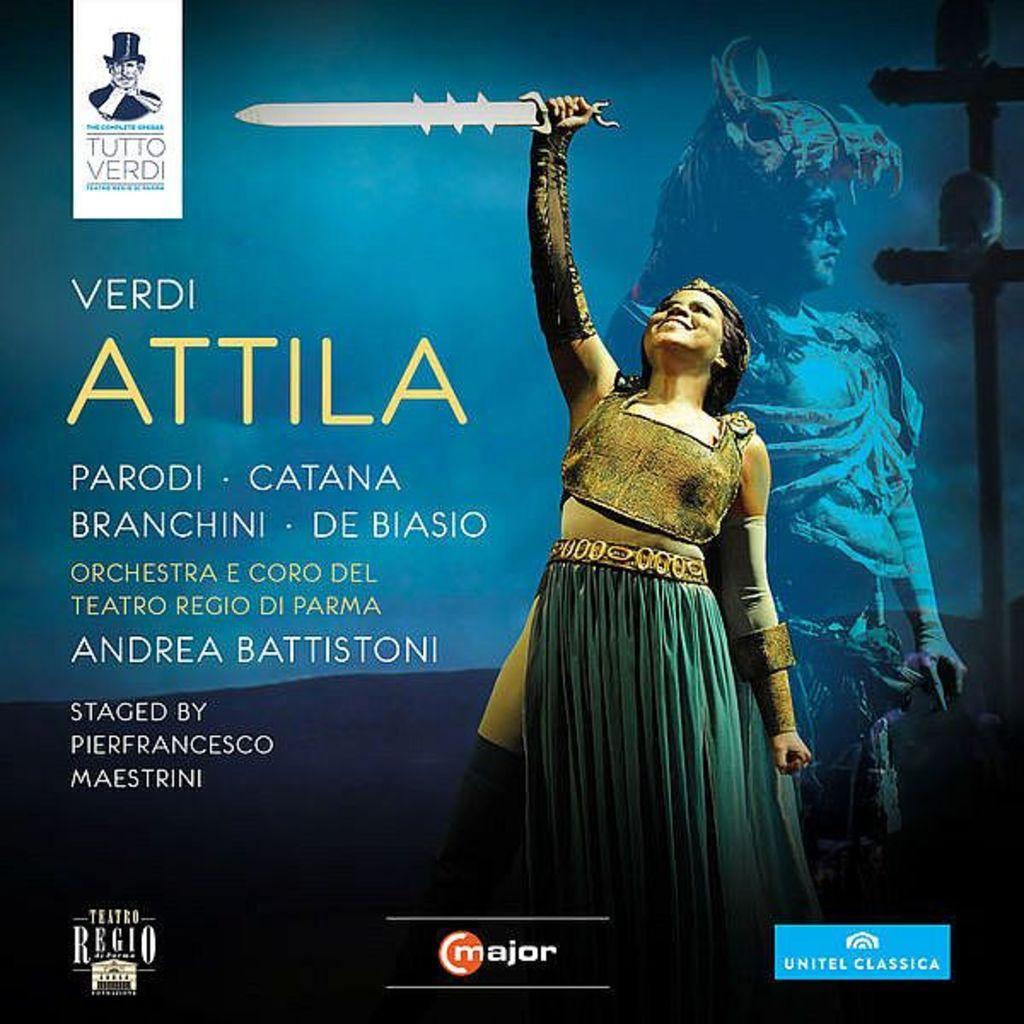Describe this image in one or two sentences. In the image we can see a woman wearing clothes and holding a sword in her hand, this is a printed text. 